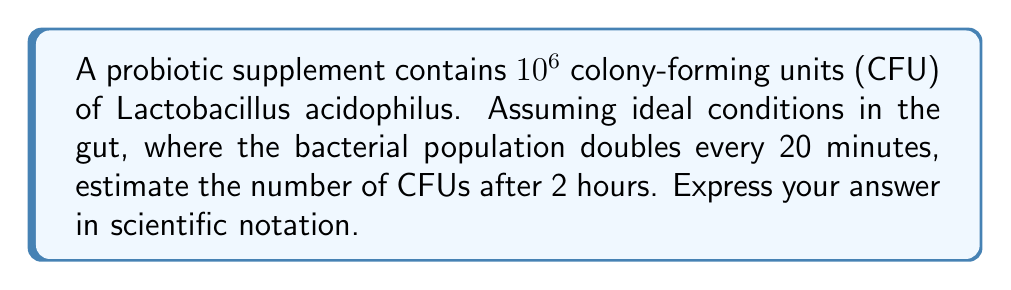Provide a solution to this math problem. To solve this problem, we need to follow these steps:

1. Determine the number of doubling periods in 2 hours:
   - 2 hours = 120 minutes
   - Each doubling period is 20 minutes
   - Number of doubling periods = 120 ÷ 20 = 6

2. Use the exponential growth formula:
   $$N = N_0 \cdot 2^n$$
   Where:
   $N$ = final number of CFUs
   $N_0$ = initial number of CFUs ($10^6$)
   $n$ = number of doubling periods (6)

3. Plug in the values:
   $$N = 10^6 \cdot 2^6$$

4. Simplify:
   $$N = 10^6 \cdot 64$$
   $$N = 64 \cdot 10^6$$

5. Convert to scientific notation:
   $$N = 6.4 \cdot 10^7$$

This calculation estimates the growth of Lactobacillus acidophilus in ideal gut conditions over a 2-hour period, which is relevant for studying probiotic effectiveness in the gut-brain axis.
Answer: $6.4 \cdot 10^7$ CFUs 